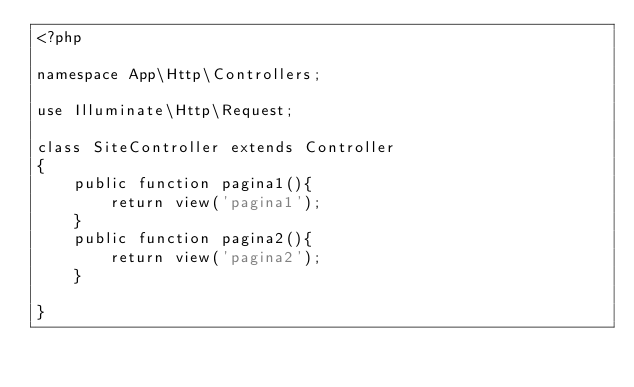Convert code to text. <code><loc_0><loc_0><loc_500><loc_500><_PHP_><?php

namespace App\Http\Controllers;

use Illuminate\Http\Request;

class SiteController extends Controller
{
    public function pagina1(){
        return view('pagina1');
    }
    public function pagina2(){
        return view('pagina2');
    }
    
}   

</code> 